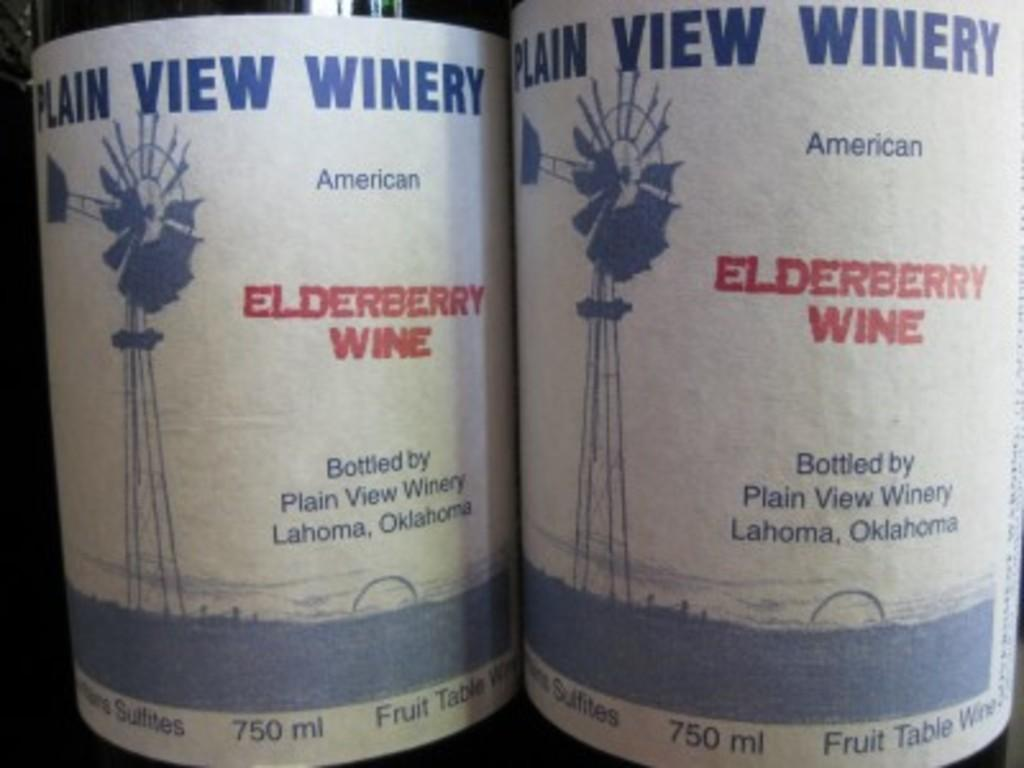Provide a one-sentence caption for the provided image. Plain View Winery is located in Oklahoma according to their labels. 